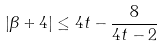Convert formula to latex. <formula><loc_0><loc_0><loc_500><loc_500>| \beta + 4 | \leq 4 t - \frac { 8 } { 4 t - 2 }</formula> 